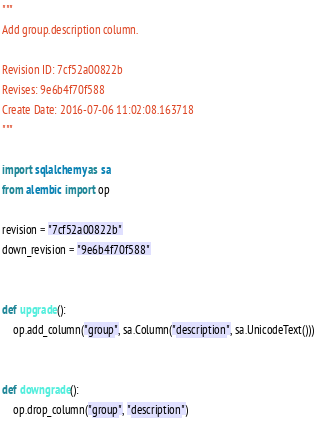<code> <loc_0><loc_0><loc_500><loc_500><_Python_>"""
Add group.description column.

Revision ID: 7cf52a00822b
Revises: 9e6b4f70f588
Create Date: 2016-07-06 11:02:08.163718
"""

import sqlalchemy as sa
from alembic import op

revision = "7cf52a00822b"
down_revision = "9e6b4f70f588"


def upgrade():
    op.add_column("group", sa.Column("description", sa.UnicodeText()))


def downgrade():
    op.drop_column("group", "description")
</code> 